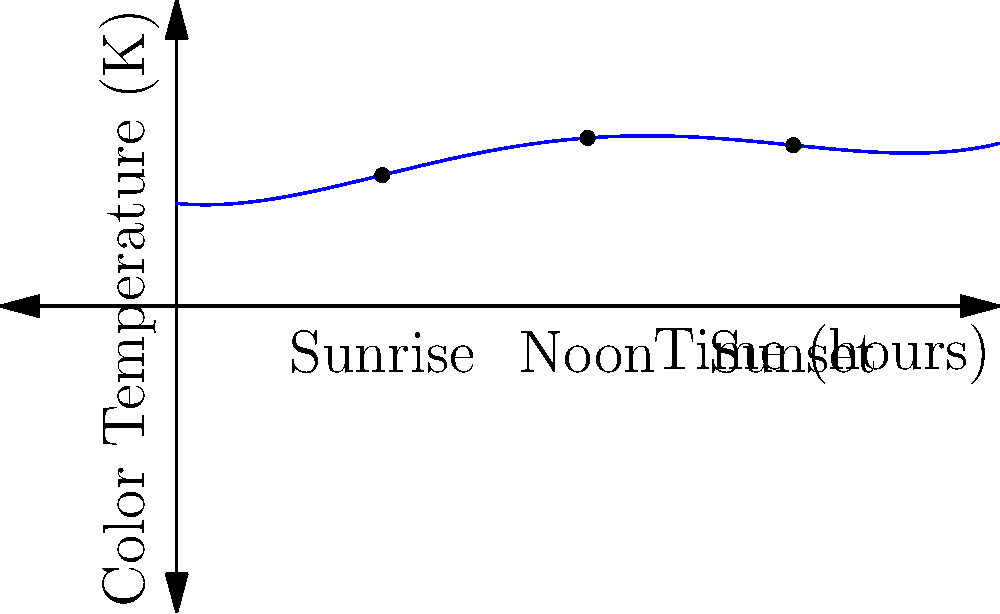Given the polynomial graph representing color temperature changes throughout the day, which of the following best describes the lighting effect at noon (12 hours) compared to sunrise (6 hours) and sunset (18 hours)? To answer this question, we need to analyze the polynomial graph and compare the values at different times:

1. Identify key points:
   - Sunrise: 6 hours
   - Noon: 12 hours
   - Sunset: 18 hours

2. Evaluate the function at these points:
   Let $f(x)$ be our polynomial function.
   
   $f(6) \approx 3.1$ (Sunrise)
   $f(12) \approx 6.5$ (Noon)
   $f(18) \approx 3.7$ (Sunset)

3. Compare the values:
   - Noon (12 hours) has the highest value, indicating the highest color temperature.
   - Sunrise and sunset have lower values, with sunrise slightly lower than sunset.

4. Interpret the results:
   - Higher color temperature corresponds to cooler, bluer light.
   - Lower color temperature corresponds to warmer, more orange light.

5. Conclusion:
   At noon, the light has the highest color temperature, resulting in cooler, bluer light compared to the warmer, more orange light at sunrise and sunset.
Answer: Cooler, bluer light at noon; warmer, more orange light at sunrise and sunset. 